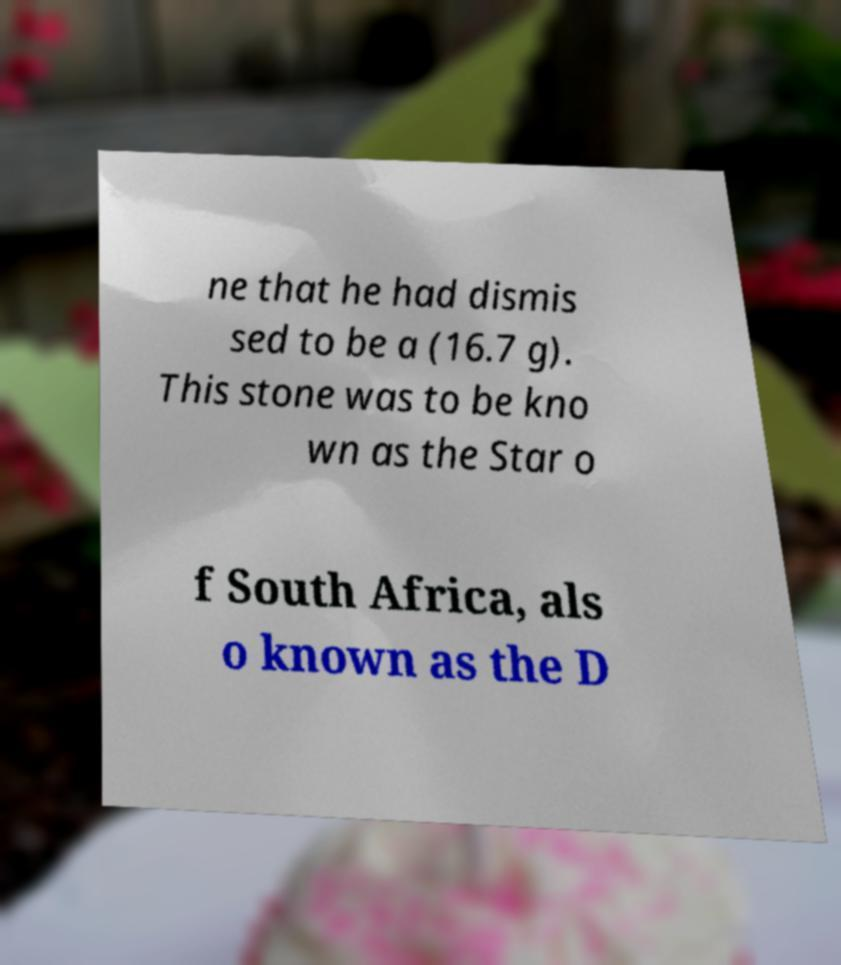Could you assist in decoding the text presented in this image and type it out clearly? ne that he had dismis sed to be a (16.7 g). This stone was to be kno wn as the Star o f South Africa, als o known as the D 